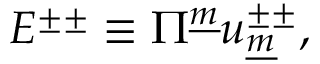<formula> <loc_0><loc_0><loc_500><loc_500>E ^ { \pm \pm } \equiv \Pi ^ { \underline { m } } u _ { \underline { m } } ^ { \pm \pm } ,</formula> 